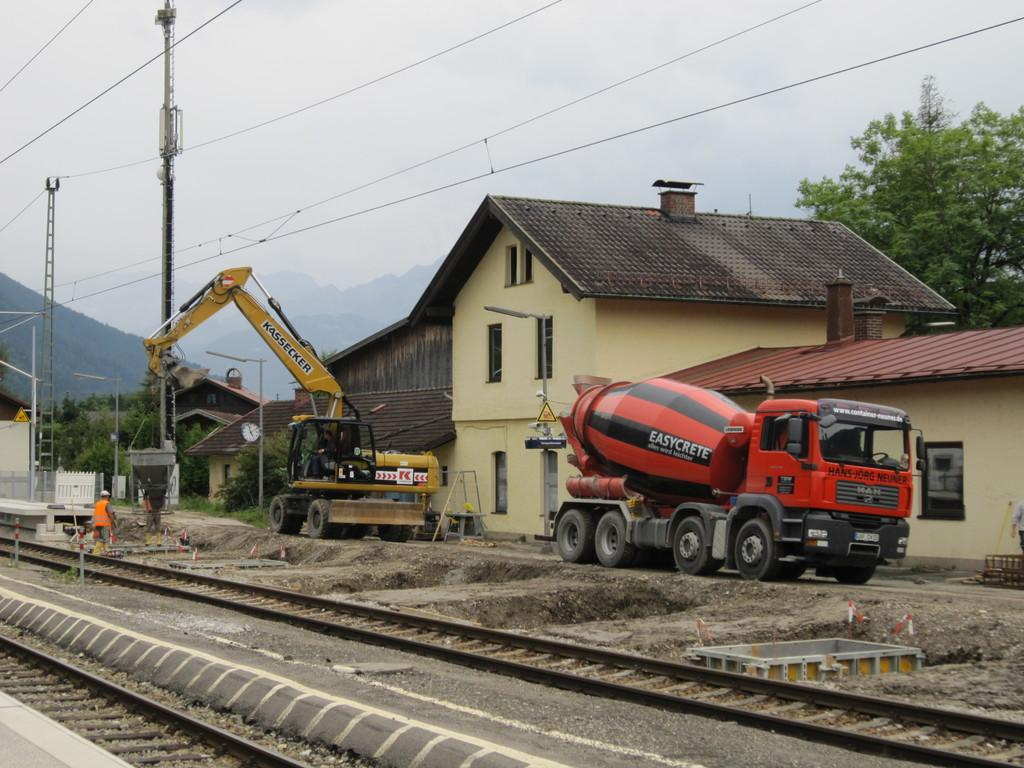<image>
Render a clear and concise summary of the photo. A red and black cement truck called Easycrete is at a construction site. 